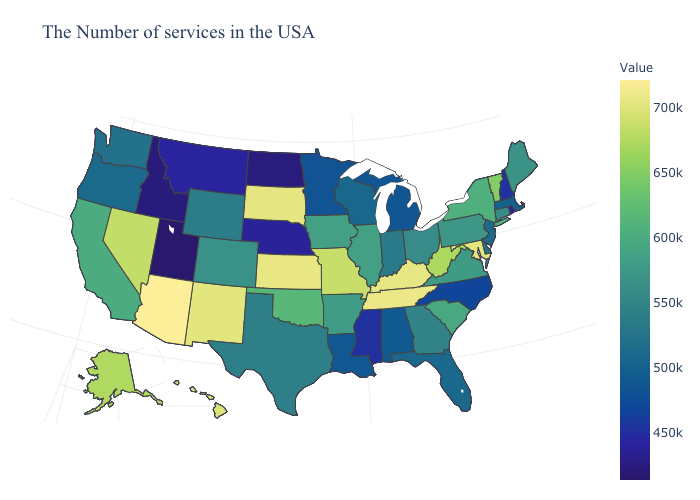Which states have the lowest value in the USA?
Give a very brief answer. Utah. Does Utah have the lowest value in the USA?
Short answer required. Yes. Does the map have missing data?
Answer briefly. No. Among the states that border Nevada , does Arizona have the highest value?
Write a very short answer. Yes. Does Utah have the lowest value in the USA?
Keep it brief. Yes. 